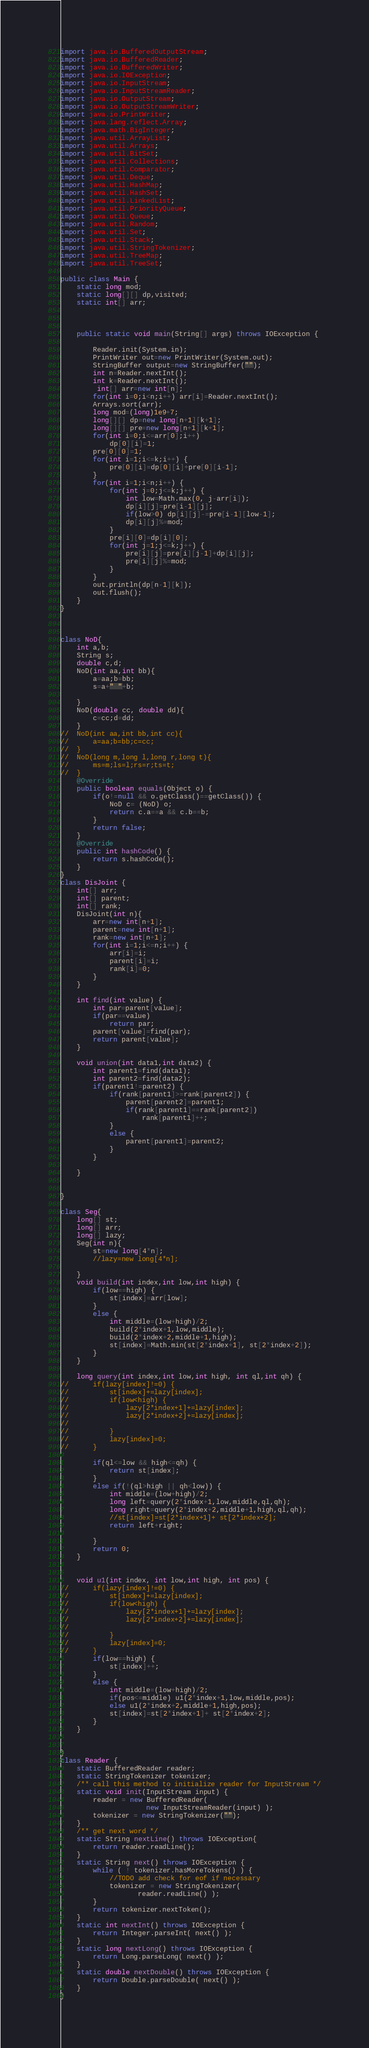Convert code to text. <code><loc_0><loc_0><loc_500><loc_500><_Java_>import java.io.BufferedOutputStream;
import java.io.BufferedReader;
import java.io.BufferedWriter;
import java.io.IOException;
import java.io.InputStream;
import java.io.InputStreamReader;
import java.io.OutputStream;
import java.io.OutputStreamWriter;
import java.io.PrintWriter;
import java.lang.reflect.Array;
import java.math.BigInteger;
import java.util.ArrayList;
import java.util.Arrays;
import java.util.BitSet;
import java.util.Collections;
import java.util.Comparator;
import java.util.Deque;
import java.util.HashMap;
import java.util.HashSet;
import java.util.LinkedList;
import java.util.PriorityQueue;
import java.util.Queue;
import java.util.Random;
import java.util.Set;
import java.util.Stack;
import java.util.StringTokenizer;
import java.util.TreeMap;
import java.util.TreeSet;

public class Main {
	static long mod;
	static long[][] dp,visited;
	static int[] arr;
	
	
	
	public static void main(String[] args) throws IOException {
		
		Reader.init(System.in);
		PrintWriter out=new PrintWriter(System.out);
		StringBuffer output=new StringBuffer("");
		int n=Reader.nextInt();
		int k=Reader.nextInt();
		 int[] arr=new int[n];
		for(int i=0;i<n;i++) arr[i]=Reader.nextInt();
		Arrays.sort(arr);
		long mod=(long)1e9+7;
		long[][] dp=new long[n+1][k+1];
		long[][] pre=new long[n+1][k+1];
		for(int i=0;i<=arr[0];i++)
			dp[0][i]=1;
		pre[0][0]=1;
		for(int i=1;i<=k;i++) {
			pre[0][i]=dp[0][i]+pre[0][i-1];
		}
		for(int i=1;i<n;i++) {
			for(int j=0;j<=k;j++) {
				int low=Math.max(0, j-arr[i]);
				dp[i][j]=pre[i-1][j];
				if(low>0) dp[i][j]-=pre[i-1][low-1];
				dp[i][j]%=mod;
			}
			pre[i][0]=dp[i][0];
			for(int j=1;j<=k;j++) {
				pre[i][j]=pre[i][j-1]+dp[i][j];
				pre[i][j]%=mod;
			}
		}
		out.println(dp[n-1][k]);
		out.flush();
	}
}



class NoD{
	int a,b;
	String s;
	double c,d;
	NoD(int aa,int bb){
		a=aa;b=bb;
		s=a+" "+b;
		
	}
	NoD(double cc, double dd){
		c=cc;d=dd;
	}
//	NoD(int aa,int bb,int cc){
//		a=aa;b=bb;c=cc;
//	}
//	NoD(long m,long l,long r,long t){
//		ms=m;ls=l;rs=r;ts=t;
//	}
	@Override
	public boolean equals(Object o) {
		if(o!=null && o.getClass()==getClass()) {
			NoD c= (NoD) o;
			return c.a==a && c.b==b;
		}
		return false;
	}
	@Override
	public int hashCode() {
		return s.hashCode();
	}
}
class DisJoint {
	int[] arr;
	int[] parent;
	int[] rank;
	DisJoint(int n){
		arr=new int[n+1];
		parent=new int[n+1];
		rank=new int[n+1];
		for(int i=1;i<=n;i++) {
			arr[i]=i;
			parent[i]=i;
			rank[i]=0;
		}
	}

	int find(int value) {
		int par=parent[value];
		if(par==value)
			return par;
		parent[value]=find(par);
		return parent[value];
	}
	
	void union(int data1,int data2) {
		int parent1=find(data1);
		int parent2=find(data2);
		if(parent1!=parent2) {
			if(rank[parent1]>=rank[parent2]) {
				parent[parent2]=parent1;
				if(rank[parent1]==rank[parent2])
					rank[parent1]++;
			}
			else {
				parent[parent1]=parent2;
			}
		}
		
	}
	

}

class Seg{
	long[] st;
	long[] arr;
	long[] lazy;
	Seg(int n){
		st=new long[4*n];
		//lazy=new long[4*n];
		
	}
	void build(int index,int low,int high) {
		if(low==high) {
			st[index]=arr[low];
		}
		else {
			int middle=(low+high)/2;
			build(2*index+1,low,middle);
			build(2*index+2,middle+1,high);
			st[index]=Math.min(st[2*index+1], st[2*index+2]);
		}
	}
	
	long query(int index,int low,int high, int ql,int qh) {
//		if(lazy[index]!=0) {
//			st[index]+=lazy[index];
//			if(low<high) {
//				lazy[2*index+1]+=lazy[index];
//				lazy[2*index+2]+=lazy[index];
//				
//			}
//			lazy[index]=0;
//		}
		
		if(ql<=low && high<=qh) {
			return st[index];
		}
		else if(!(ql>high || qh<low)) {
			int middle=(low+high)/2;
			long left=query(2*index+1,low,middle,ql,qh);
			long right=query(2*index+2,middle+1,high,ql,qh);
			//st[index]=st[2*index+1]+ st[2*index+2];
			return left+right;
			
		}
		return 0;
	}
	
	
	void u1(int index, int low,int high, int pos) {
//		if(lazy[index]!=0) {
//			st[index]+=lazy[index];
//			if(low<high) {
//				lazy[2*index+1]+=lazy[index];
//				lazy[2*index+2]+=lazy[index];
//				
//			}
//			lazy[index]=0;
//		}
		if(low==high) {
			st[index]++;
		}
		else {
			int middle=(low+high)/2;
			if(pos<=middle) u1(2*index+1,low,middle,pos);
			else u1(2*index+2,middle+1,high,pos);
			st[index]=st[2*index+1]+ st[2*index+2];
		}
	}
	
	
}
class Reader {
    static BufferedReader reader;
    static StringTokenizer tokenizer;
    /** call this method to initialize reader for InputStream */
    static void init(InputStream input) {
        reader = new BufferedReader(
                     new InputStreamReader(input) );
        tokenizer = new StringTokenizer("");
    }
    /** get next word */
    static String nextLine() throws IOException{
    	return reader.readLine();
    }
    static String next() throws IOException {
        while ( ! tokenizer.hasMoreTokens() ) {
            //TODO add check for eof if necessary
            tokenizer = new StringTokenizer(
                   reader.readLine() );
        }
        return tokenizer.nextToken();
    }
    static int nextInt() throws IOException {
        return Integer.parseInt( next() );
    }
    static long nextLong() throws IOException {
        return Long.parseLong( next() );
    }
    static double nextDouble() throws IOException {
        return Double.parseDouble( next() );
    }
}</code> 